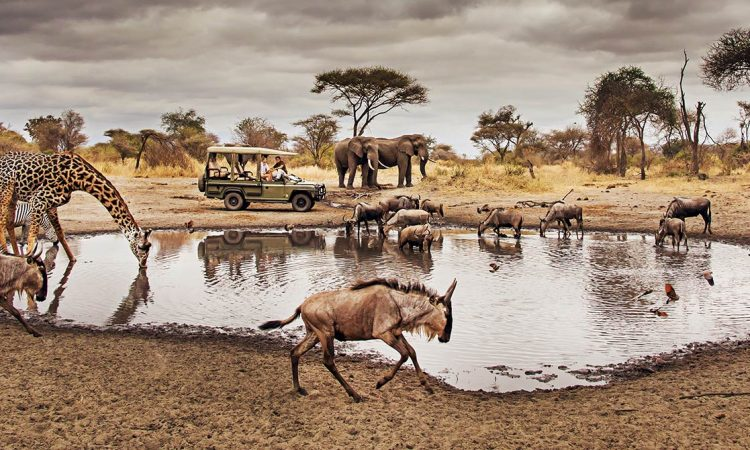If you could ask the giraffe a question, what would it be? If I could ask the giraffe a question, I would ask: 'What is it like to see the world from such a great height and to traverse the vast savannah with such grace?' What sculptural form would represent this scene in a museum, and what materials would you use? In a museum, this scene could be represented by a dynamic, life-sized diorama featuring sculpted versions of the giraffe, wildebeests, and elephants around a shimmering 'water' installation. The giraffe would be sculpted at full height, using a combination of resin and fiberglass to capture its sleek form and distinctive patterns. The wildebeests would be crafted from bronze to emphasize their sturdy yet cautious nature, while the elephants could be rendered in a blend of reclaimed wood and clay to convey their grandeur and deep connection to the earth. The watering hole could be created with polished glass and reflective materials to mimic the appearance of water. The surrounding base would replicate the dry, cracked mud and sparse vegetation found in the savannah, grounding the entire piece in authenticity. 